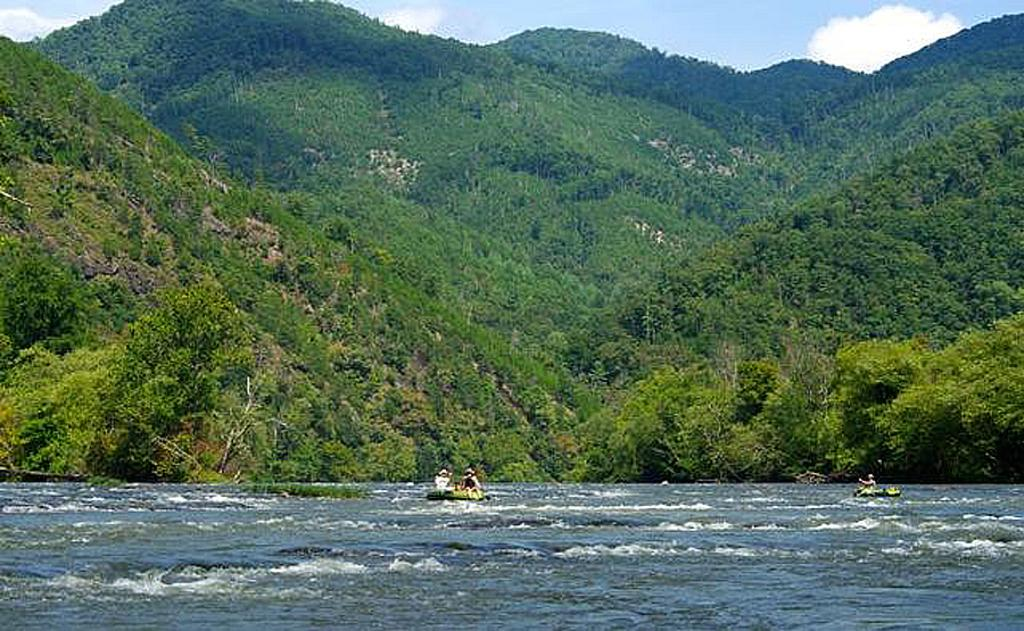How many boats can be seen in the image? There are two boats in the image. Where are the boats located? The boats are on the water. Can you describe the people in the image? There are persons in the image. What type of vegetation is visible in the image? There are trees in the image. What is visible in the sky in the image? The sky is visible in the image, and clouds are present. What type of silver object is being used to tell a fictional story in the image? There is no silver object or fictional story present in the image. 